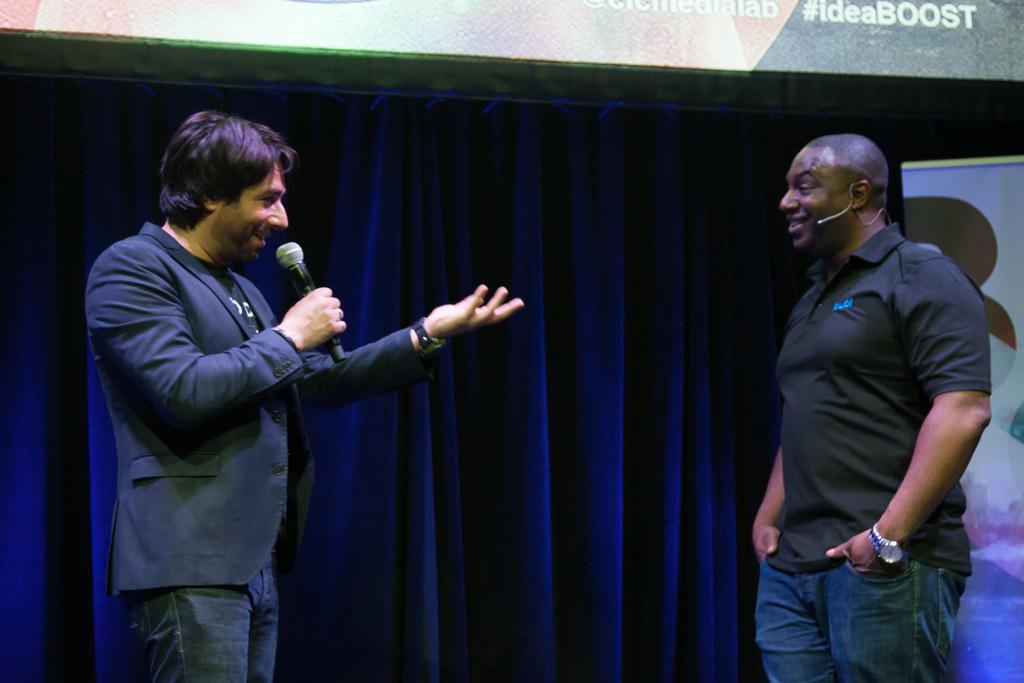Describe this image in one or two sentences. In this picture these two persons are standing. This person holding microphone. On the background we can see curtain,banner. 